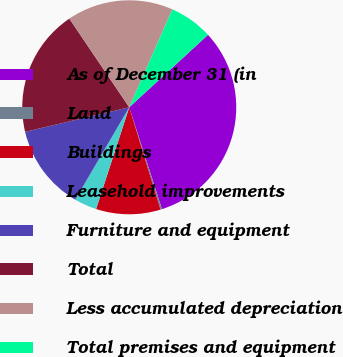Convert chart to OTSL. <chart><loc_0><loc_0><loc_500><loc_500><pie_chart><fcel>As of December 31 (in<fcel>Land<fcel>Buildings<fcel>Leasehold improvements<fcel>Furniture and equipment<fcel>Total<fcel>Less accumulated depreciation<fcel>Total premises and equipment<nl><fcel>31.89%<fcel>0.23%<fcel>9.73%<fcel>3.4%<fcel>12.9%<fcel>19.23%<fcel>16.06%<fcel>6.56%<nl></chart> 